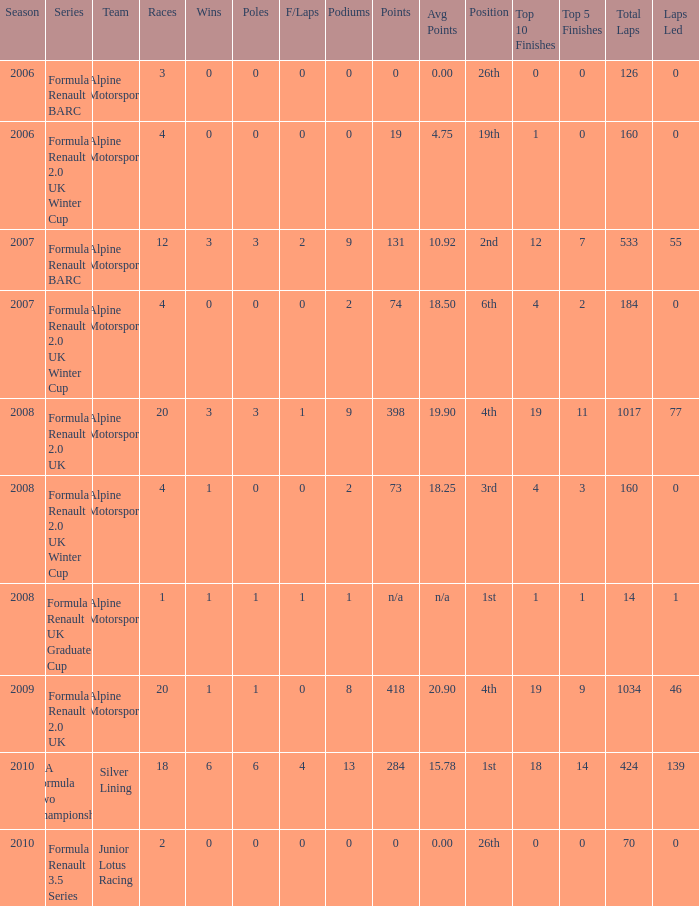How much were the f/laps if poles is higher than 1.0 during 2008? 1.0. 